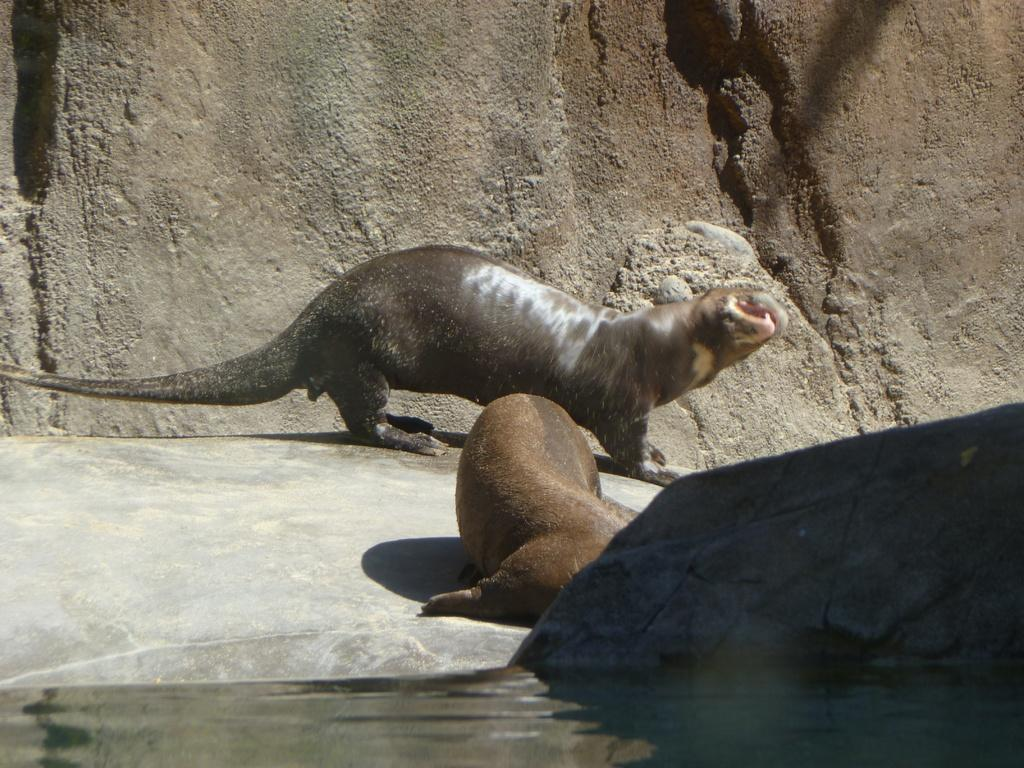What is located in the center of the image? There are animals in the center of the image. What is at the bottom of the image? There is a river at the bottom of the image. What can be seen in the background of the image? There are mountains visible in the background of the image. What is the price of the paper in the image? There is no paper present in the image, so it is not possible to determine the price. What type of pipe can be seen in the image? There is no pipe present in the image. 